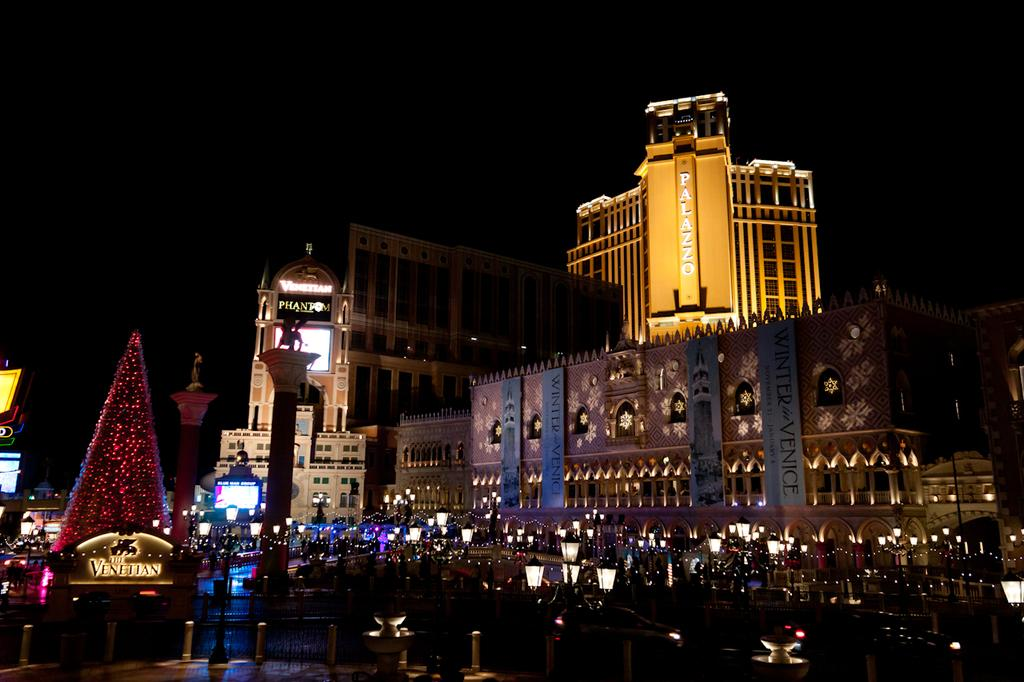What type of structures can be seen in the image? There are buildings in the image. What type of lights are visible in the image? There are decoration lights and street lights in the image. How would you describe the lighting conditions in the image? The background of the image is dark. What type of card is being used to collect sugar in the image? There is no card or sugar present in the image. 